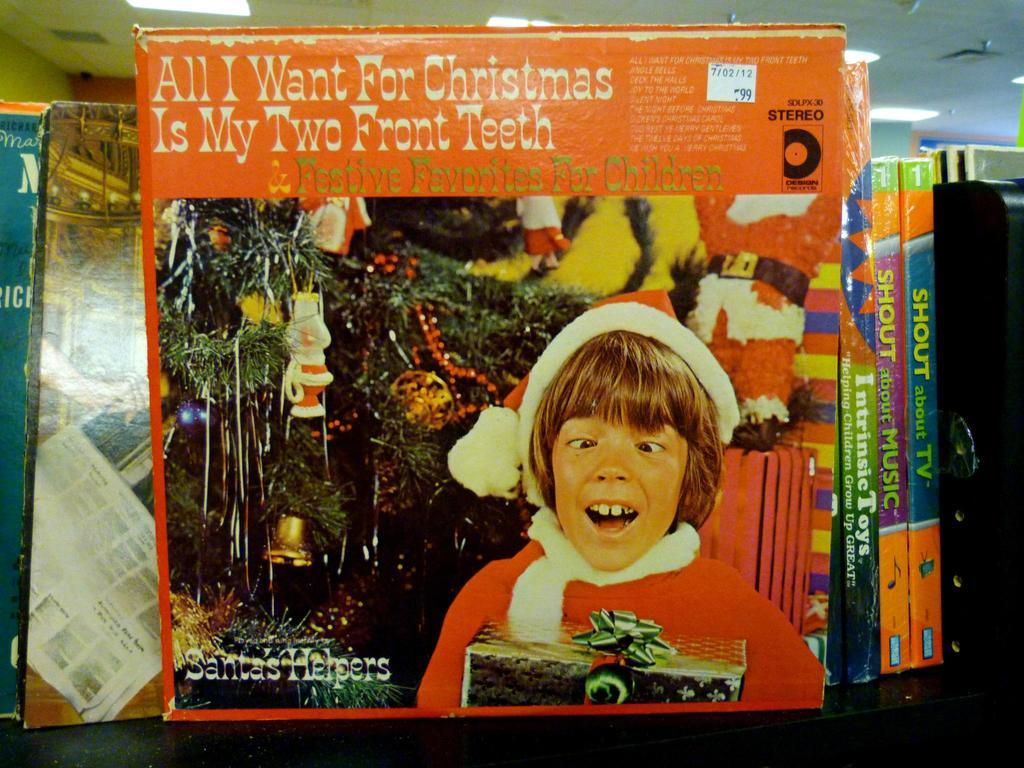What is the main subject of the image? There is a group of books in the image. Where are the books located? The books are on a surface. What can be seen on the book? There is a picture of a person on the book. What else is present on the book? There is text on the book. What is visible at the top of the image? The roof and lights are present at the top of the image. What type of soup is being served in the image? There is no soup present in the image; it features a group of books on a surface. What type of building is shown in the image? The image does not show a building; it features a group of books on a surface with a roof and lights visible at the top. 